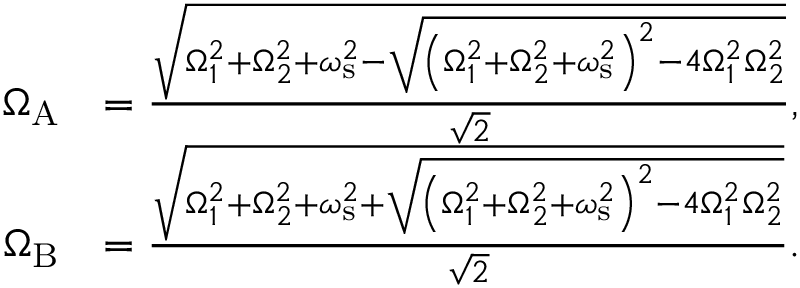Convert formula to latex. <formula><loc_0><loc_0><loc_500><loc_500>\begin{array} { r l } { \Omega _ { A } } & { = \frac { \sqrt { \Omega _ { 1 } ^ { 2 } + \Omega _ { 2 } ^ { 2 } + \omega _ { s } ^ { 2 } - \sqrt { \left ( \Omega _ { 1 } ^ { 2 } + \Omega _ { 2 } ^ { 2 } + \omega _ { s } ^ { 2 } \right ) ^ { 2 } - 4 \Omega _ { 1 } ^ { 2 } \Omega _ { 2 } ^ { 2 } } } } { \sqrt { 2 } } , } \\ { \Omega _ { B } } & { = \frac { \sqrt { \Omega _ { 1 } ^ { 2 } + \Omega _ { 2 } ^ { 2 } + \omega _ { s } ^ { 2 } + \sqrt { \left ( \Omega _ { 1 } ^ { 2 } + \Omega _ { 2 } ^ { 2 } + \omega _ { s } ^ { 2 } \right ) ^ { 2 } - 4 \Omega _ { 1 } ^ { 2 } \Omega _ { 2 } ^ { 2 } } } } { \sqrt { 2 } } . } \end{array}</formula> 